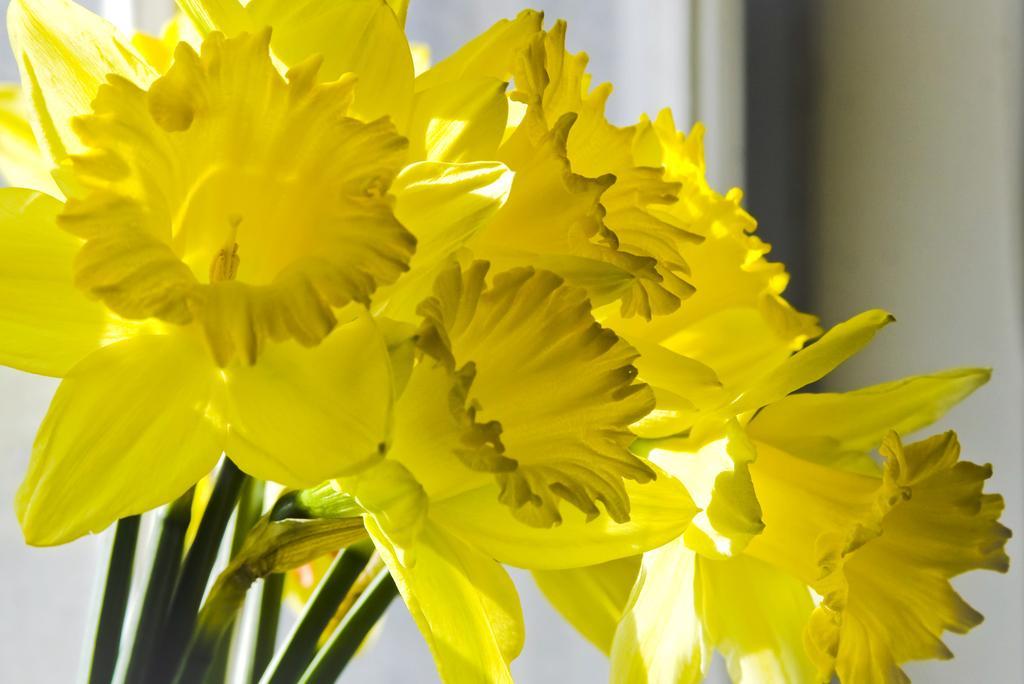How would you summarize this image in a sentence or two? In this image we can see group of flowers on stems. In the background, we can see the wall. 